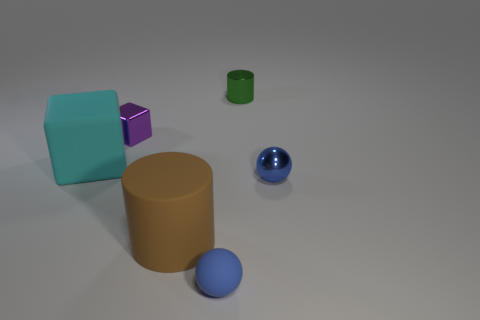What is the tiny sphere that is left of the metal cylinder made of? The sphere appears to have a reflective surface similar to that of the metal cylinder, suggesting it could be made of a polished material such as metal or glass. Due to the image quality and lighting, it is difficult to determine the exact material with certainty without further context. 